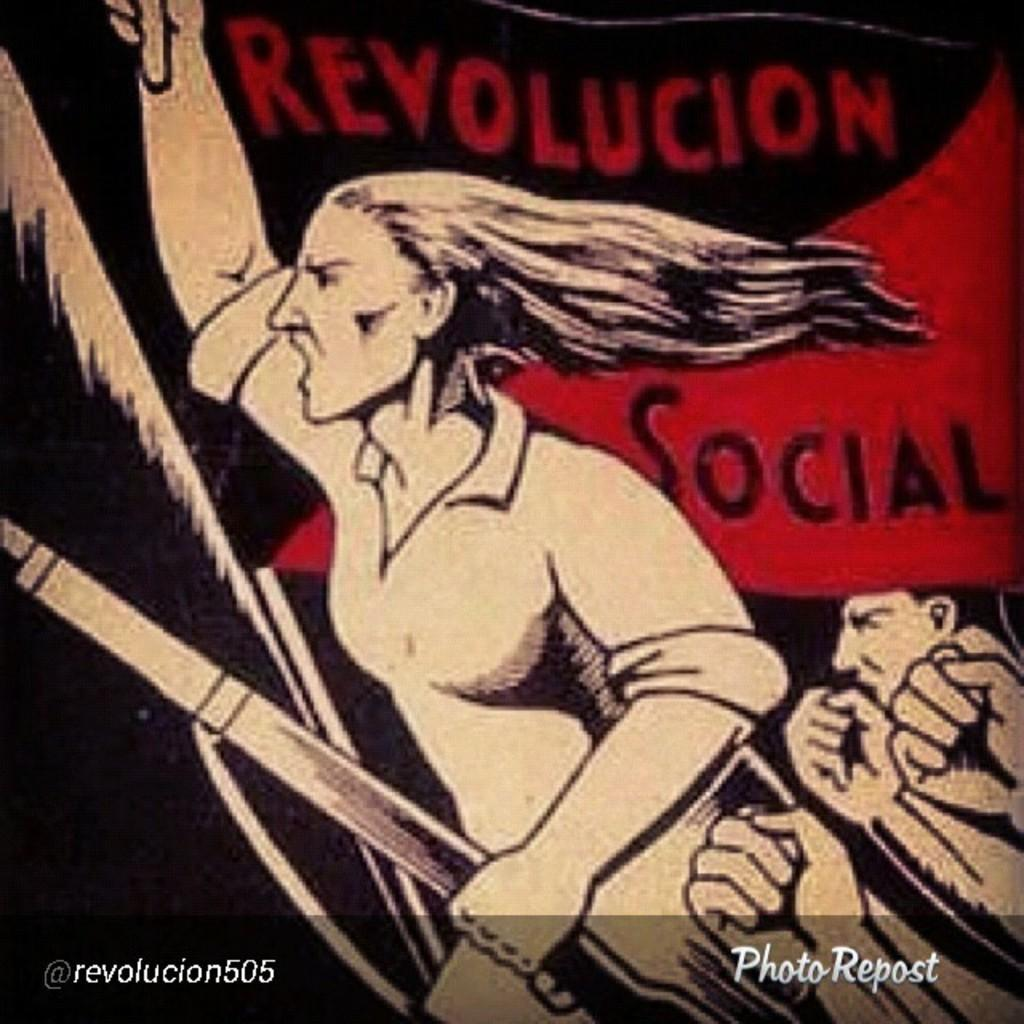<image>
Provide a brief description of the given image. A Photo Repost for @revolucion505 is shown with angry characters that says Revolucion Social in the background. 